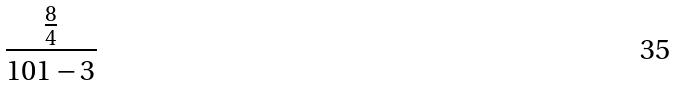Convert formula to latex. <formula><loc_0><loc_0><loc_500><loc_500>\frac { \frac { 8 } { 4 } } { 1 0 1 - 3 }</formula> 